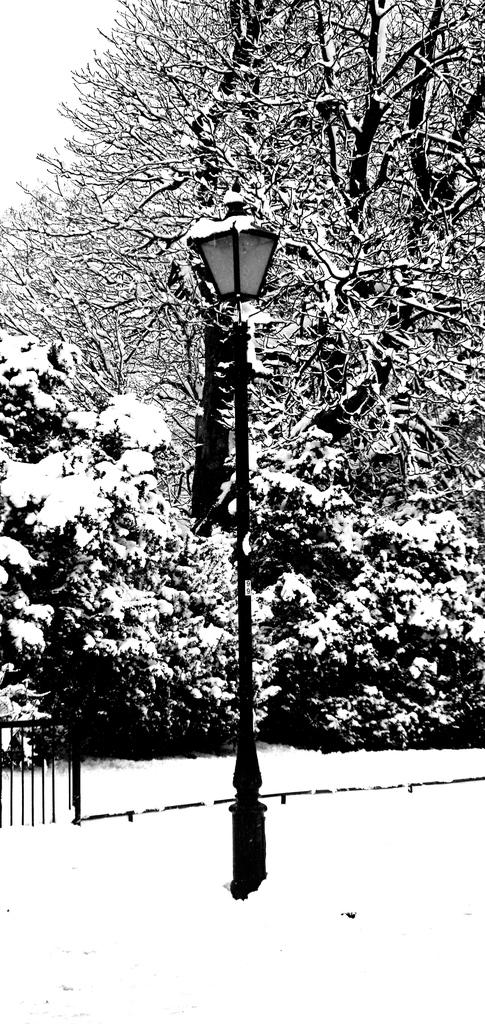What is the color scheme of the image? The image is black and white. What type of weather is depicted in the image? There is snowfall in the image. What structure can be seen in the image? There is a light pole in the image. What type of barrier is present in the image? There is a fence in the image. How are the trees affected by the weather in the image? The trees are covered with snow in the image. What type of show is being performed in the image? There is no show being performed in the image; it depicts snowfall and a black and white landscape. What type of drum can be seen in the image? There is no drum present in the image. 